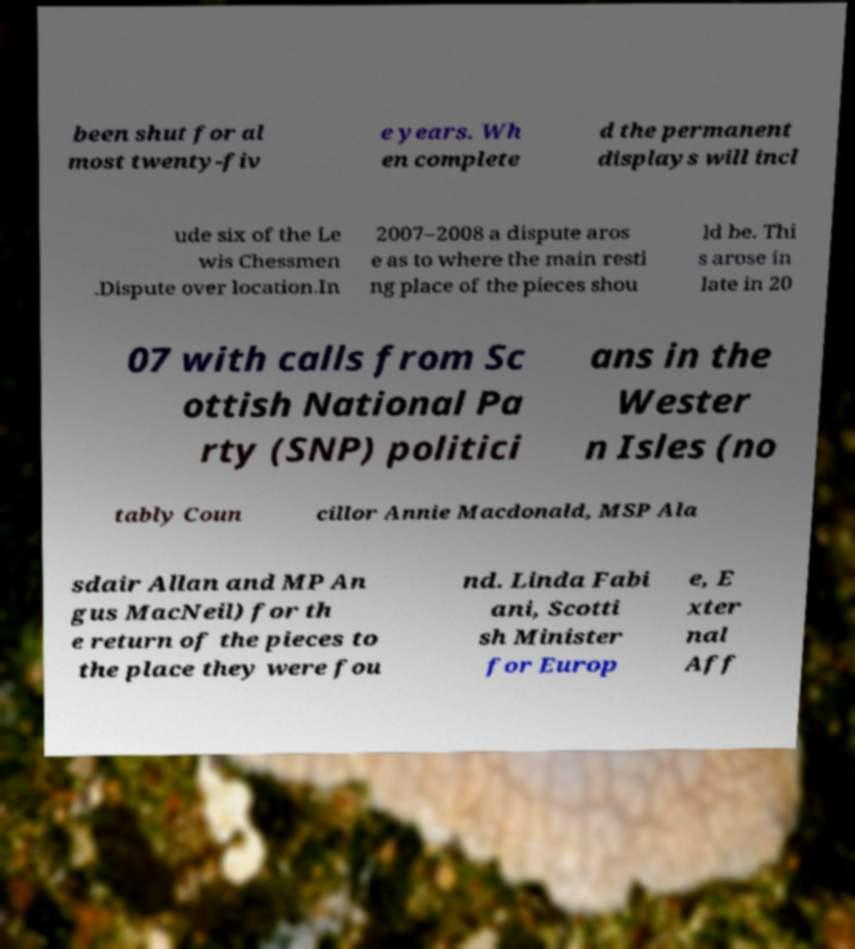There's text embedded in this image that I need extracted. Can you transcribe it verbatim? been shut for al most twenty-fiv e years. Wh en complete d the permanent displays will incl ude six of the Le wis Chessmen .Dispute over location.In 2007–2008 a dispute aros e as to where the main resti ng place of the pieces shou ld be. Thi s arose in late in 20 07 with calls from Sc ottish National Pa rty (SNP) politici ans in the Wester n Isles (no tably Coun cillor Annie Macdonald, MSP Ala sdair Allan and MP An gus MacNeil) for th e return of the pieces to the place they were fou nd. Linda Fabi ani, Scotti sh Minister for Europ e, E xter nal Aff 